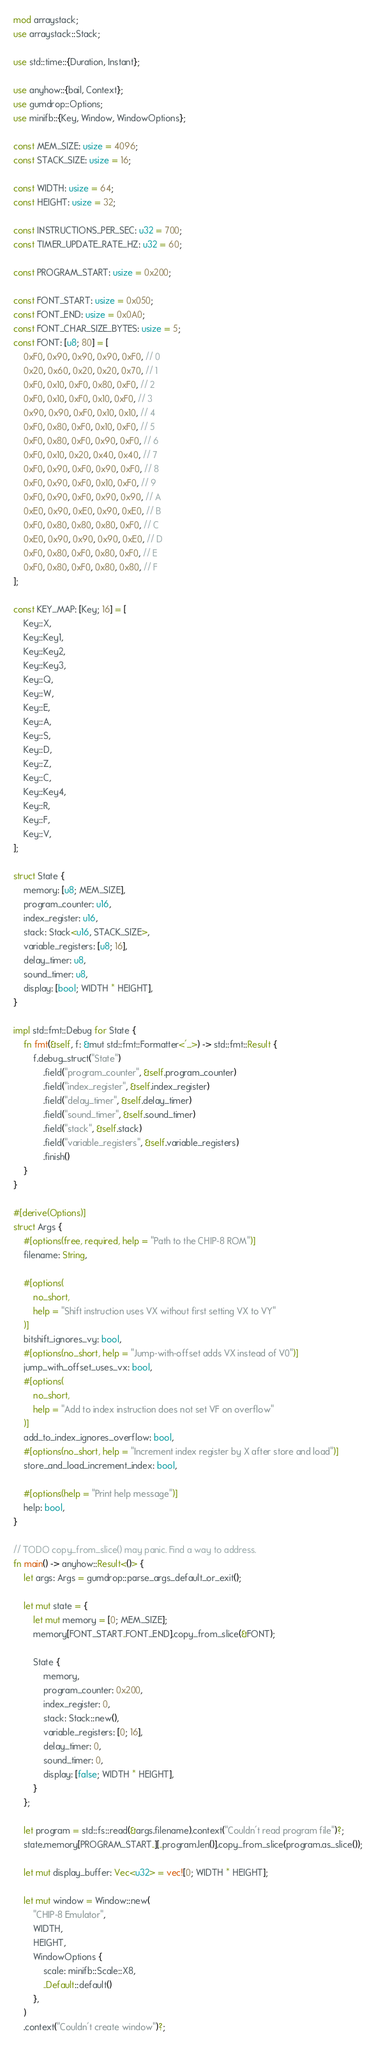<code> <loc_0><loc_0><loc_500><loc_500><_Rust_>mod arraystack;
use arraystack::Stack;

use std::time::{Duration, Instant};

use anyhow::{bail, Context};
use gumdrop::Options;
use minifb::{Key, Window, WindowOptions};

const MEM_SIZE: usize = 4096;
const STACK_SIZE: usize = 16;

const WIDTH: usize = 64;
const HEIGHT: usize = 32;

const INSTRUCTIONS_PER_SEC: u32 = 700;
const TIMER_UPDATE_RATE_HZ: u32 = 60;

const PROGRAM_START: usize = 0x200;

const FONT_START: usize = 0x050;
const FONT_END: usize = 0x0A0;
const FONT_CHAR_SIZE_BYTES: usize = 5;
const FONT: [u8; 80] = [
    0xF0, 0x90, 0x90, 0x90, 0xF0, // 0
    0x20, 0x60, 0x20, 0x20, 0x70, // 1
    0xF0, 0x10, 0xF0, 0x80, 0xF0, // 2
    0xF0, 0x10, 0xF0, 0x10, 0xF0, // 3
    0x90, 0x90, 0xF0, 0x10, 0x10, // 4
    0xF0, 0x80, 0xF0, 0x10, 0xF0, // 5
    0xF0, 0x80, 0xF0, 0x90, 0xF0, // 6
    0xF0, 0x10, 0x20, 0x40, 0x40, // 7
    0xF0, 0x90, 0xF0, 0x90, 0xF0, // 8
    0xF0, 0x90, 0xF0, 0x10, 0xF0, // 9
    0xF0, 0x90, 0xF0, 0x90, 0x90, // A
    0xE0, 0x90, 0xE0, 0x90, 0xE0, // B
    0xF0, 0x80, 0x80, 0x80, 0xF0, // C
    0xE0, 0x90, 0x90, 0x90, 0xE0, // D
    0xF0, 0x80, 0xF0, 0x80, 0xF0, // E
    0xF0, 0x80, 0xF0, 0x80, 0x80, // F
];

const KEY_MAP: [Key; 16] = [
    Key::X,
    Key::Key1,
    Key::Key2,
    Key::Key3,
    Key::Q,
    Key::W,
    Key::E,
    Key::A,
    Key::S,
    Key::D,
    Key::Z,
    Key::C,
    Key::Key4,
    Key::R,
    Key::F,
    Key::V,
];

struct State {
    memory: [u8; MEM_SIZE],
    program_counter: u16,
    index_register: u16,
    stack: Stack<u16, STACK_SIZE>,
    variable_registers: [u8; 16],
    delay_timer: u8,
    sound_timer: u8,
    display: [bool; WIDTH * HEIGHT],
}

impl std::fmt::Debug for State {
    fn fmt(&self, f: &mut std::fmt::Formatter<'_>) -> std::fmt::Result {
        f.debug_struct("State")
            .field("program_counter", &self.program_counter)
            .field("index_register", &self.index_register)
            .field("delay_timer", &self.delay_timer)
            .field("sound_timer", &self.sound_timer)
            .field("stack", &self.stack)
            .field("variable_registers", &self.variable_registers)
            .finish()
    }
}

#[derive(Options)]
struct Args {
    #[options(free, required, help = "Path to the CHIP-8 ROM")]
    filename: String,

    #[options(
        no_short,
        help = "Shift instruction uses VX without first setting VX to VY"
    )]
    bitshift_ignores_vy: bool,
    #[options(no_short, help = "Jump-with-offset adds VX instead of V0")]
    jump_with_offset_uses_vx: bool,
    #[options(
        no_short,
        help = "Add to index instruction does not set VF on overflow"
    )]
    add_to_index_ignores_overflow: bool,
    #[options(no_short, help = "Increment index register by X after store and load")]
    store_and_load_increment_index: bool,

    #[options(help = "Print help message")]
    help: bool,
}

// TODO copy_from_slice() may panic. Find a way to address.
fn main() -> anyhow::Result<()> {
    let args: Args = gumdrop::parse_args_default_or_exit();

    let mut state = {
        let mut memory = [0; MEM_SIZE];
        memory[FONT_START..FONT_END].copy_from_slice(&FONT);

        State {
            memory,
            program_counter: 0x200,
            index_register: 0,
            stack: Stack::new(),
            variable_registers: [0; 16],
            delay_timer: 0,
            sound_timer: 0,
            display: [false; WIDTH * HEIGHT],
        }
    };

    let program = std::fs::read(&args.filename).context("Couldn't read program file")?;
    state.memory[PROGRAM_START..][..program.len()].copy_from_slice(program.as_slice());

    let mut display_buffer: Vec<u32> = vec![0; WIDTH * HEIGHT];

    let mut window = Window::new(
        "CHIP-8 Emulator",
        WIDTH,
        HEIGHT,
        WindowOptions {
            scale: minifb::Scale::X8,
            ..Default::default()
        },
    )
    .context("Couldn't create window")?;
</code> 